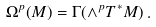Convert formula to latex. <formula><loc_0><loc_0><loc_500><loc_500>\Omega ^ { p } ( M ) = \Gamma ( \wedge ^ { p } T ^ { * } M ) \, .</formula> 